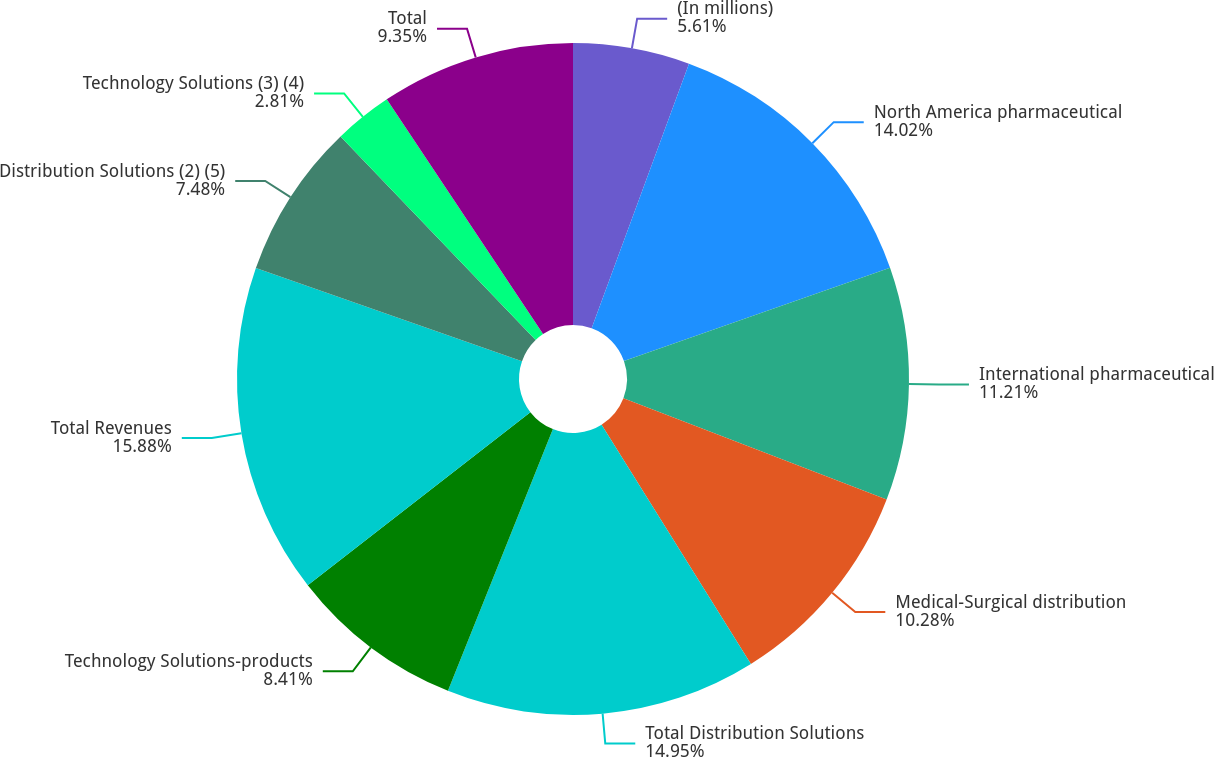Convert chart to OTSL. <chart><loc_0><loc_0><loc_500><loc_500><pie_chart><fcel>(In millions)<fcel>North America pharmaceutical<fcel>International pharmaceutical<fcel>Medical-Surgical distribution<fcel>Total Distribution Solutions<fcel>Technology Solutions-products<fcel>Total Revenues<fcel>Distribution Solutions (2) (5)<fcel>Technology Solutions (3) (4)<fcel>Total<nl><fcel>5.61%<fcel>14.02%<fcel>11.21%<fcel>10.28%<fcel>14.95%<fcel>8.41%<fcel>15.88%<fcel>7.48%<fcel>2.81%<fcel>9.35%<nl></chart> 